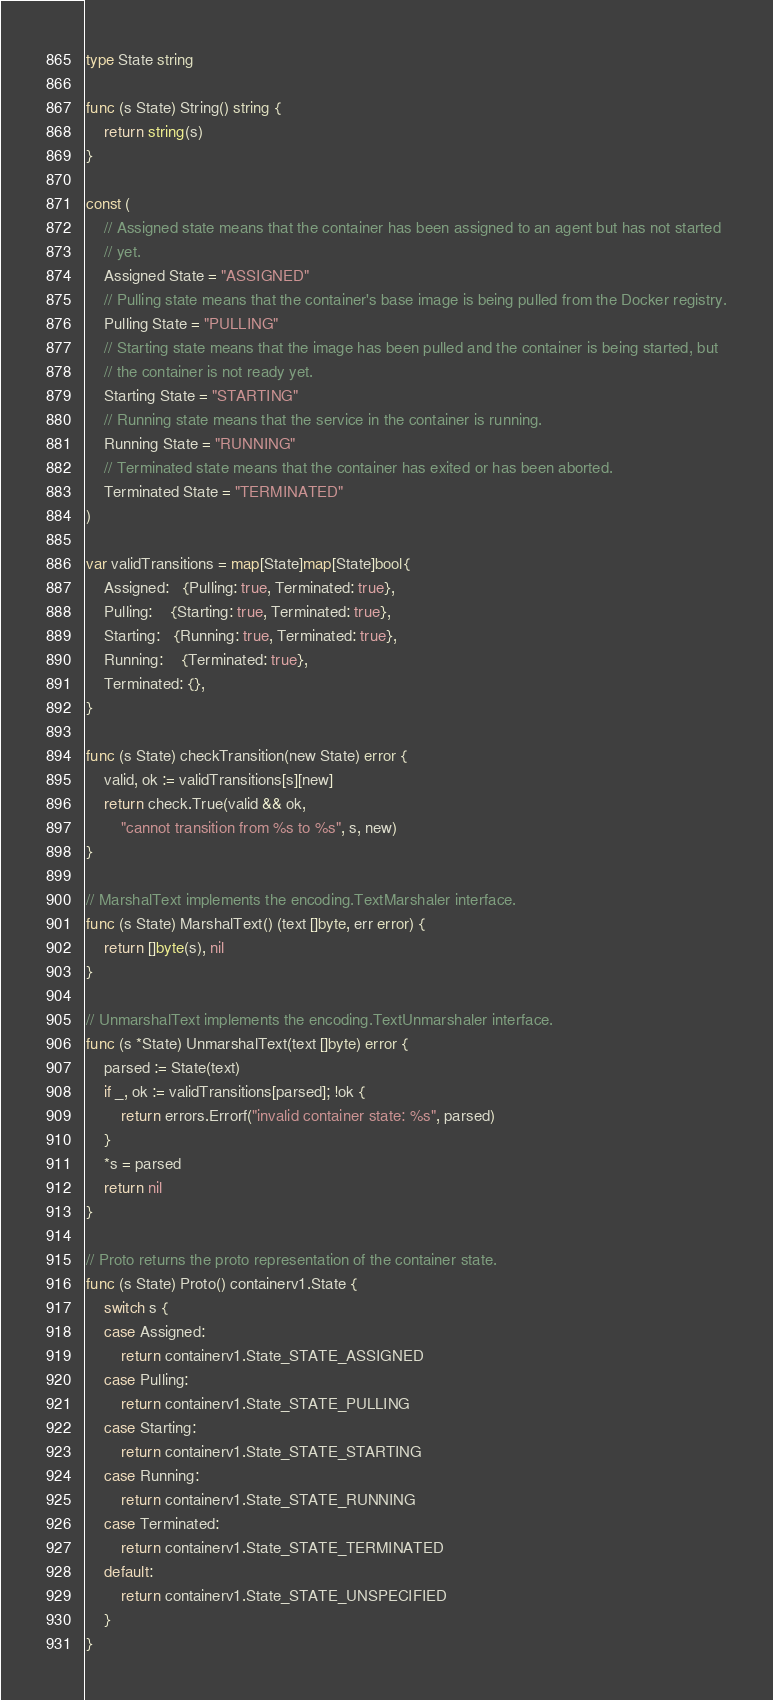Convert code to text. <code><loc_0><loc_0><loc_500><loc_500><_Go_>type State string

func (s State) String() string {
	return string(s)
}

const (
	// Assigned state means that the container has been assigned to an agent but has not started
	// yet.
	Assigned State = "ASSIGNED"
	// Pulling state means that the container's base image is being pulled from the Docker registry.
	Pulling State = "PULLING"
	// Starting state means that the image has been pulled and the container is being started, but
	// the container is not ready yet.
	Starting State = "STARTING"
	// Running state means that the service in the container is running.
	Running State = "RUNNING"
	// Terminated state means that the container has exited or has been aborted.
	Terminated State = "TERMINATED"
)

var validTransitions = map[State]map[State]bool{
	Assigned:   {Pulling: true, Terminated: true},
	Pulling:    {Starting: true, Terminated: true},
	Starting:   {Running: true, Terminated: true},
	Running:    {Terminated: true},
	Terminated: {},
}

func (s State) checkTransition(new State) error {
	valid, ok := validTransitions[s][new]
	return check.True(valid && ok,
		"cannot transition from %s to %s", s, new)
}

// MarshalText implements the encoding.TextMarshaler interface.
func (s State) MarshalText() (text []byte, err error) {
	return []byte(s), nil
}

// UnmarshalText implements the encoding.TextUnmarshaler interface.
func (s *State) UnmarshalText(text []byte) error {
	parsed := State(text)
	if _, ok := validTransitions[parsed]; !ok {
		return errors.Errorf("invalid container state: %s", parsed)
	}
	*s = parsed
	return nil
}

// Proto returns the proto representation of the container state.
func (s State) Proto() containerv1.State {
	switch s {
	case Assigned:
		return containerv1.State_STATE_ASSIGNED
	case Pulling:
		return containerv1.State_STATE_PULLING
	case Starting:
		return containerv1.State_STATE_STARTING
	case Running:
		return containerv1.State_STATE_RUNNING
	case Terminated:
		return containerv1.State_STATE_TERMINATED
	default:
		return containerv1.State_STATE_UNSPECIFIED
	}
}
</code> 